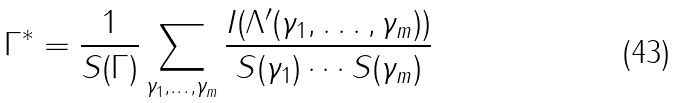<formula> <loc_0><loc_0><loc_500><loc_500>\Gamma ^ { * } = \frac { 1 } { S ( \Gamma ) } \sum _ { \gamma _ { 1 } , \dots , \gamma _ { m } } \frac { I ( \Lambda ^ { \prime } ( \gamma _ { 1 } , \dots , \gamma _ { m } ) ) } { S ( \gamma _ { 1 } ) \cdots S ( \gamma _ { m } ) }</formula> 